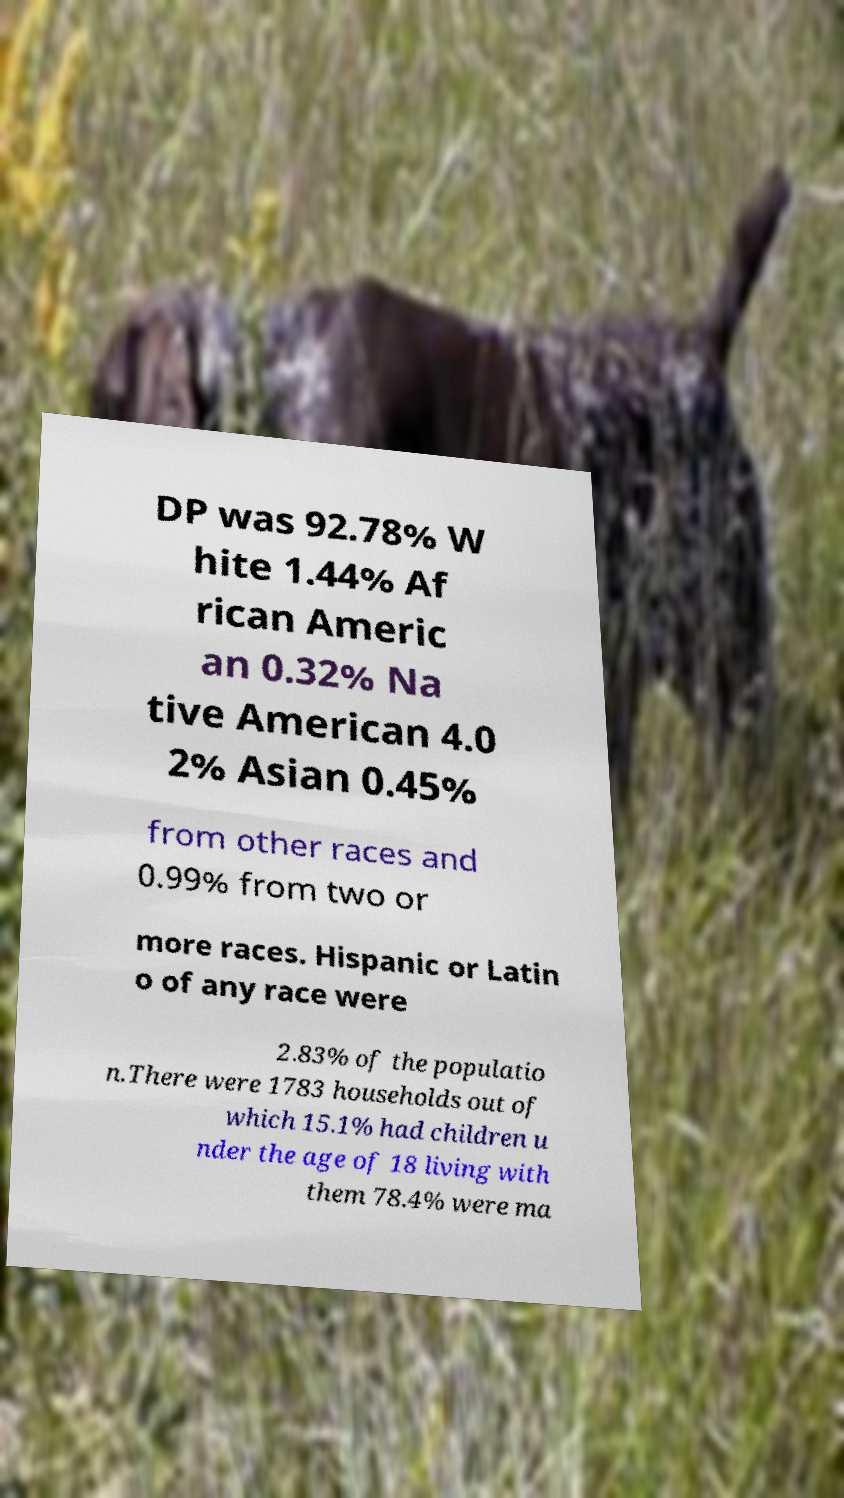What messages or text are displayed in this image? I need them in a readable, typed format. DP was 92.78% W hite 1.44% Af rican Americ an 0.32% Na tive American 4.0 2% Asian 0.45% from other races and 0.99% from two or more races. Hispanic or Latin o of any race were 2.83% of the populatio n.There were 1783 households out of which 15.1% had children u nder the age of 18 living with them 78.4% were ma 